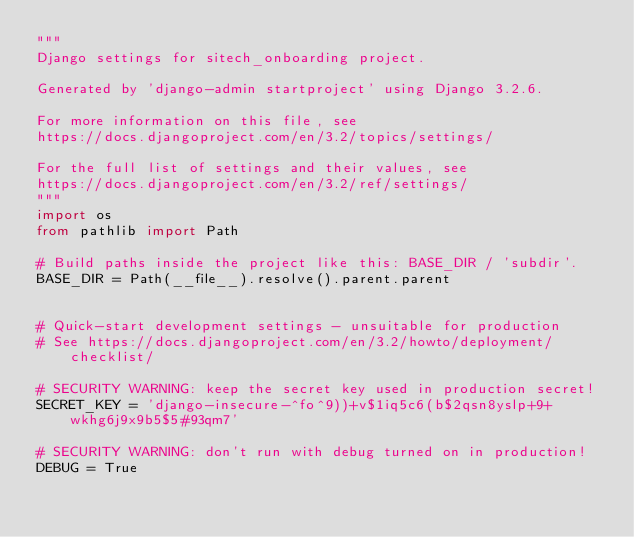Convert code to text. <code><loc_0><loc_0><loc_500><loc_500><_Python_>"""
Django settings for sitech_onboarding project.

Generated by 'django-admin startproject' using Django 3.2.6.

For more information on this file, see
https://docs.djangoproject.com/en/3.2/topics/settings/

For the full list of settings and their values, see
https://docs.djangoproject.com/en/3.2/ref/settings/
"""
import os
from pathlib import Path

# Build paths inside the project like this: BASE_DIR / 'subdir'.
BASE_DIR = Path(__file__).resolve().parent.parent


# Quick-start development settings - unsuitable for production
# See https://docs.djangoproject.com/en/3.2/howto/deployment/checklist/

# SECURITY WARNING: keep the secret key used in production secret!
SECRET_KEY = 'django-insecure-^fo^9))+v$1iq5c6(b$2qsn8yslp+9+wkhg6j9x9b5$5#93qm7'

# SECURITY WARNING: don't run with debug turned on in production!
DEBUG = True
</code> 